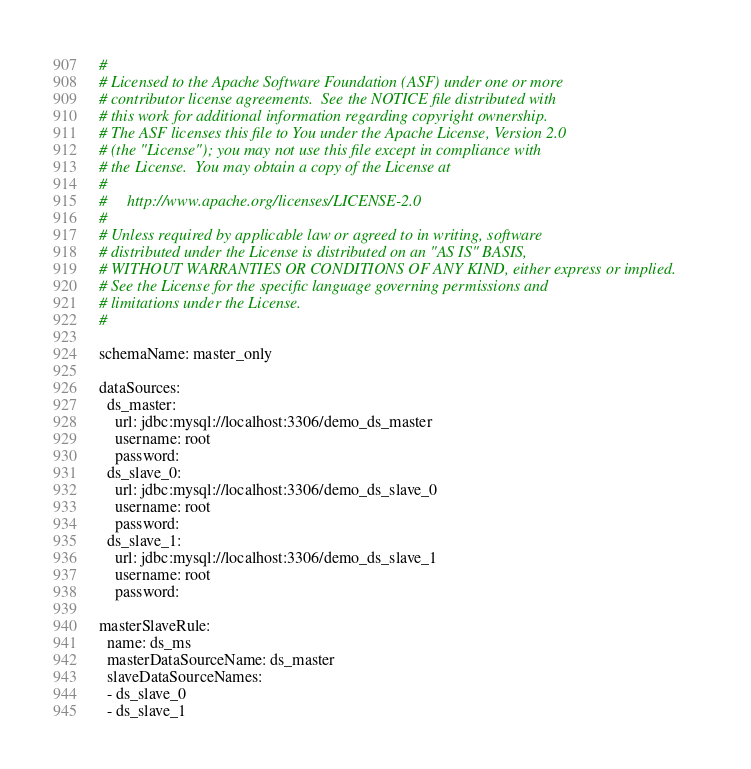<code> <loc_0><loc_0><loc_500><loc_500><_YAML_>#
# Licensed to the Apache Software Foundation (ASF) under one or more
# contributor license agreements.  See the NOTICE file distributed with
# this work for additional information regarding copyright ownership.
# The ASF licenses this file to You under the Apache License, Version 2.0
# (the "License"); you may not use this file except in compliance with
# the License.  You may obtain a copy of the License at
#
#     http://www.apache.org/licenses/LICENSE-2.0
#
# Unless required by applicable law or agreed to in writing, software
# distributed under the License is distributed on an "AS IS" BASIS,
# WITHOUT WARRANTIES OR CONDITIONS OF ANY KIND, either express or implied.
# See the License for the specific language governing permissions and
# limitations under the License.
#

schemaName: master_only

dataSources:
  ds_master:
    url: jdbc:mysql://localhost:3306/demo_ds_master
    username: root
    password:
  ds_slave_0:
    url: jdbc:mysql://localhost:3306/demo_ds_slave_0
    username: root
    password:
  ds_slave_1:
    url: jdbc:mysql://localhost:3306/demo_ds_slave_1
    username: root
    password:

masterSlaveRule:
  name: ds_ms
  masterDataSourceName: ds_master
  slaveDataSourceNames:
  - ds_slave_0
  - ds_slave_1
</code> 